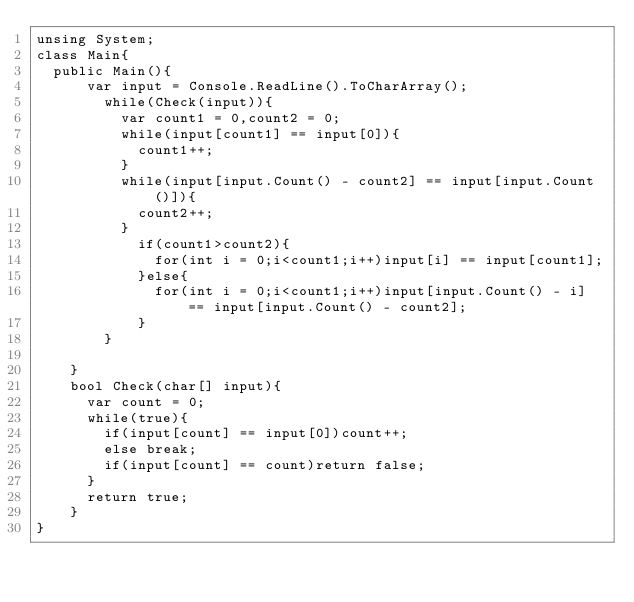<code> <loc_0><loc_0><loc_500><loc_500><_C#_>unsing System;
class Main{
	public Main(){
    	var input = Console.ReadLine().ToCharArray();
      	while(Check(input)){
        	var count1 = 0,count2 = 0;
        	while(input[count1] == input[0]){
        		count1++;
        	}
        	while(input[input.Count() - count2] == input[input.Count()]){
        		count2++;
        	}
            if(count1>count2){
            	for(int i = 0;i<count1;i++)input[i] == input[count1];
            }else{
            	for(int i = 0;i<count1;i++)input[input.Count() - i] == input[input.Count() - count2];
            }
        }
        
    }
    bool Check(char[] input){
      var count = 0;
      while(true){
        if(input[count] == input[0])count++;
        else break;
        if(input[count] == count)return false;
      }
      return true;
    }
}</code> 